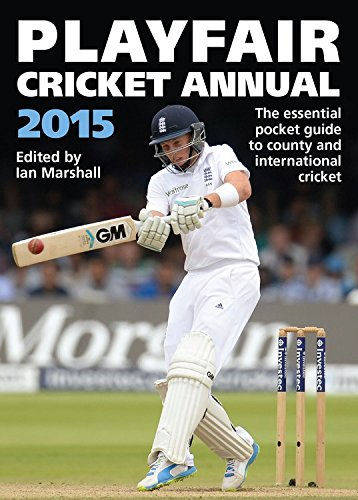Who is the author of this book? Ian Marshall edited the Playfair Cricket Annual 2015, an important distinction as he compiled and organized the information rather than writing it in the traditional sense of an author. 